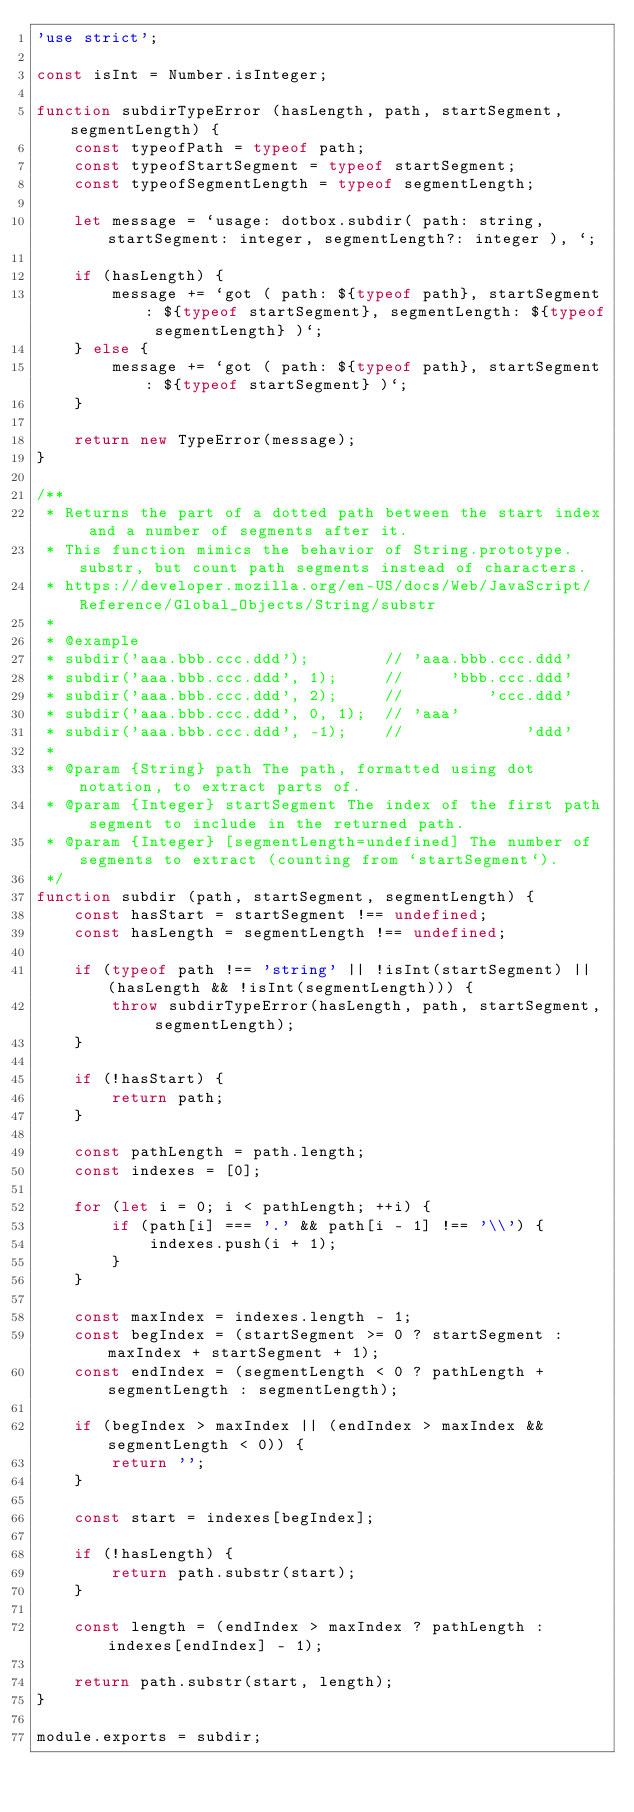<code> <loc_0><loc_0><loc_500><loc_500><_JavaScript_>'use strict';

const isInt = Number.isInteger;

function subdirTypeError (hasLength, path, startSegment, segmentLength) {
	const typeofPath = typeof path;
	const typeofStartSegment = typeof startSegment;
	const typeofSegmentLength = typeof segmentLength;

	let message = `usage: dotbox.subdir( path: string, startSegment: integer, segmentLength?: integer ), `;

	if (hasLength) {
		message += `got ( path: ${typeof path}, startSegment: ${typeof startSegment}, segmentLength: ${typeof segmentLength} )`;
	} else {
		message += `got ( path: ${typeof path}, startSegment: ${typeof startSegment} )`;
	}
	
	return new TypeError(message);
}

/**
 * Returns the part of a dotted path between the start index and a number of segments after it.
 * This function mimics the behavior of String.prototype.substr, but count path segments instead of characters.
 * https://developer.mozilla.org/en-US/docs/Web/JavaScript/Reference/Global_Objects/String/substr
 * 
 * @example
 * subdir('aaa.bbb.ccc.ddd');        // 'aaa.bbb.ccc.ddd'
 * subdir('aaa.bbb.ccc.ddd', 1);     //     'bbb.ccc.ddd'
 * subdir('aaa.bbb.ccc.ddd', 2);     //         'ccc.ddd'
 * subdir('aaa.bbb.ccc.ddd', 0, 1);  // 'aaa'
 * subdir('aaa.bbb.ccc.ddd', -1);    //             'ddd'
 * 
 * @param {String} path The path, formatted using dot notation, to extract parts of.
 * @param {Integer} startSegment The index of the first path segment to include in the returned path.
 * @param {Integer} [segmentLength=undefined] The number of segments to extract (counting from `startSegment`).
 */
function subdir (path, startSegment, segmentLength) {
    const hasStart = startSegment !== undefined;
    const hasLength = segmentLength !== undefined;

	if (typeof path !== 'string' || !isInt(startSegment) || (hasLength && !isInt(segmentLength))) {
		throw subdirTypeError(hasLength, path, startSegment, segmentLength);
	}

    if (!hasStart) {
        return path;
    }

	const pathLength = path.length;
	const indexes = [0];

	for (let i = 0; i < pathLength; ++i) {
		if (path[i] === '.' && path[i - 1] !== '\\') {
			indexes.push(i + 1);
		}
	}

	const maxIndex = indexes.length - 1;
	const begIndex = (startSegment >= 0 ? startSegment : maxIndex + startSegment + 1);
	const endIndex = (segmentLength < 0 ? pathLength + segmentLength : segmentLength);

	if (begIndex > maxIndex || (endIndex > maxIndex && segmentLength < 0)) {
		return '';
	}
	
	const start = indexes[begIndex];

	if (!hasLength) {
		return path.substr(start);
	}

    const length = (endIndex > maxIndex ? pathLength : indexes[endIndex] - 1);

    return path.substr(start, length);
}

module.exports = subdir;
</code> 